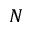<formula> <loc_0><loc_0><loc_500><loc_500>N</formula> 